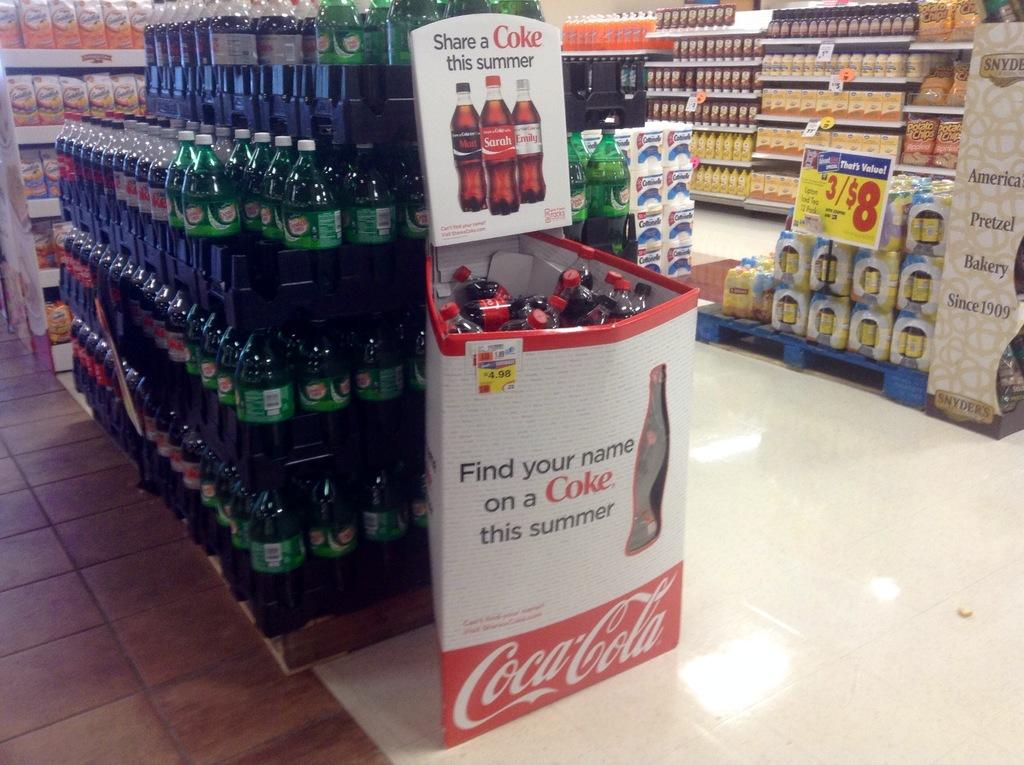Provide a one-sentence caption for the provided image. The cardboard box, in front of the bottles of soda, holds bottles of Cokes. 